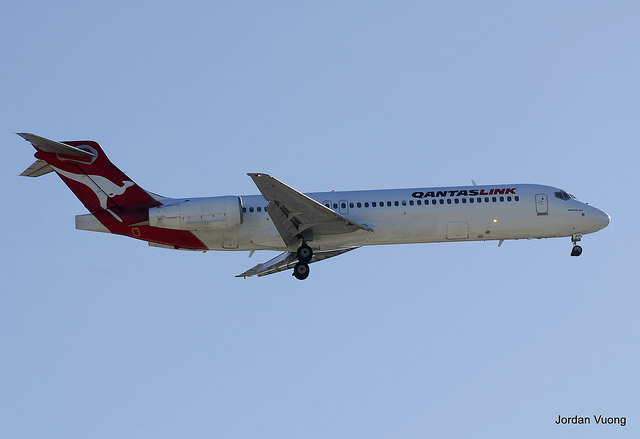Please transcribe the text information in this image. QUATASLINK Vuong Jordan 